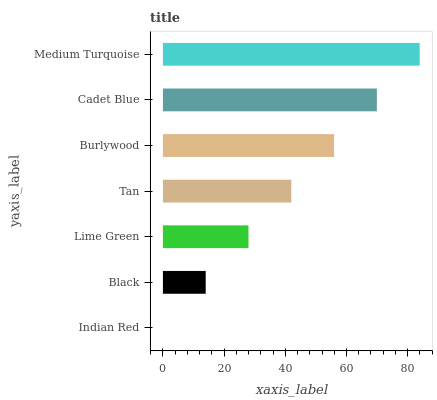Is Indian Red the minimum?
Answer yes or no. Yes. Is Medium Turquoise the maximum?
Answer yes or no. Yes. Is Black the minimum?
Answer yes or no. No. Is Black the maximum?
Answer yes or no. No. Is Black greater than Indian Red?
Answer yes or no. Yes. Is Indian Red less than Black?
Answer yes or no. Yes. Is Indian Red greater than Black?
Answer yes or no. No. Is Black less than Indian Red?
Answer yes or no. No. Is Tan the high median?
Answer yes or no. Yes. Is Tan the low median?
Answer yes or no. Yes. Is Black the high median?
Answer yes or no. No. Is Burlywood the low median?
Answer yes or no. No. 